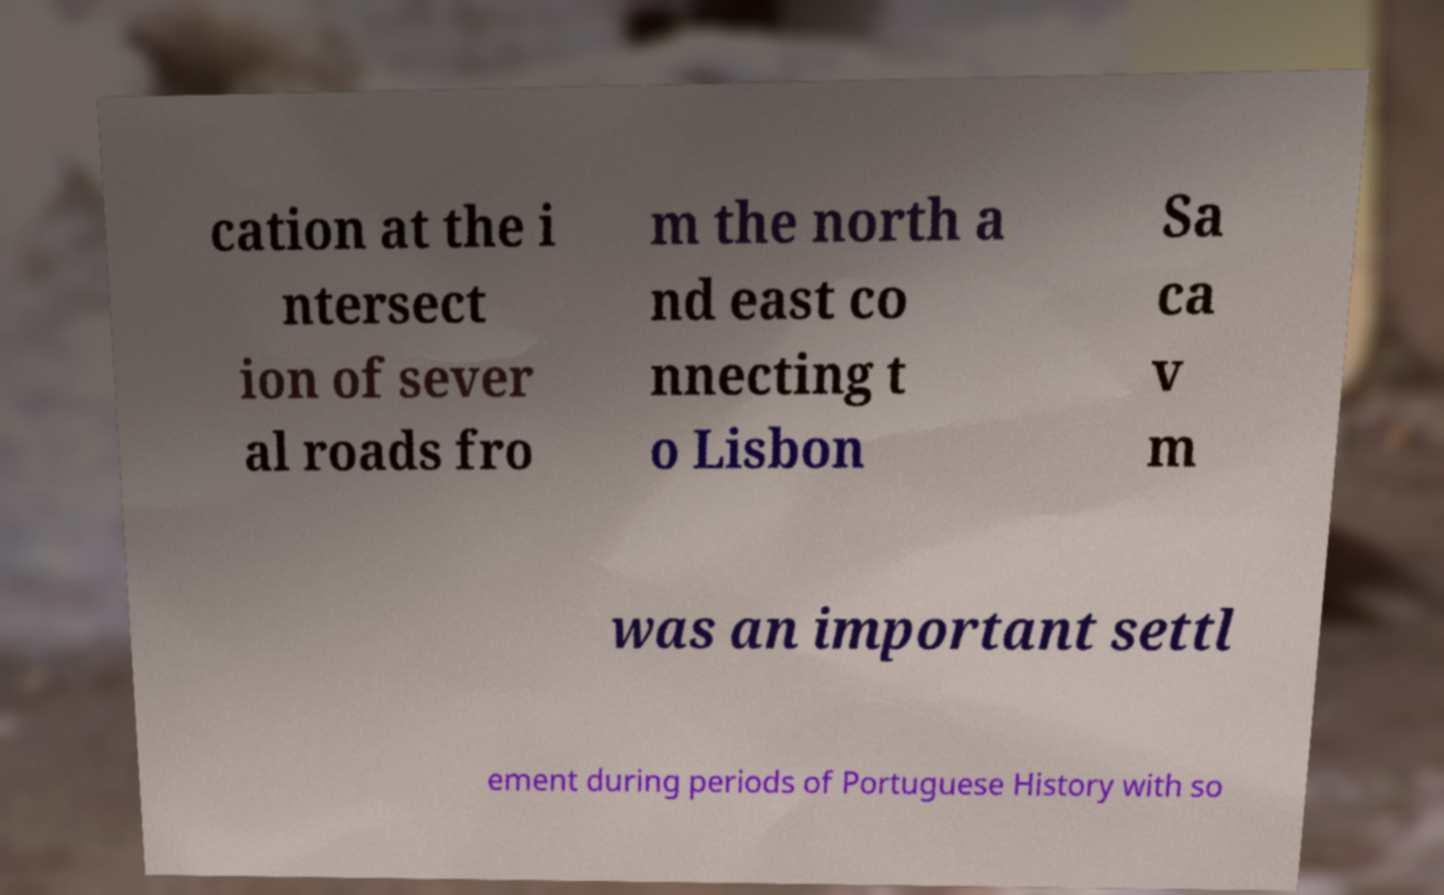Could you assist in decoding the text presented in this image and type it out clearly? cation at the i ntersect ion of sever al roads fro m the north a nd east co nnecting t o Lisbon Sa ca v m was an important settl ement during periods of Portuguese History with so 